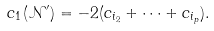<formula> <loc_0><loc_0><loc_500><loc_500>c _ { 1 } ( \mathcal { N } ^ { \prime } ) = - 2 ( c _ { i _ { 2 } } + \cdots + c _ { i _ { p } } ) .</formula> 